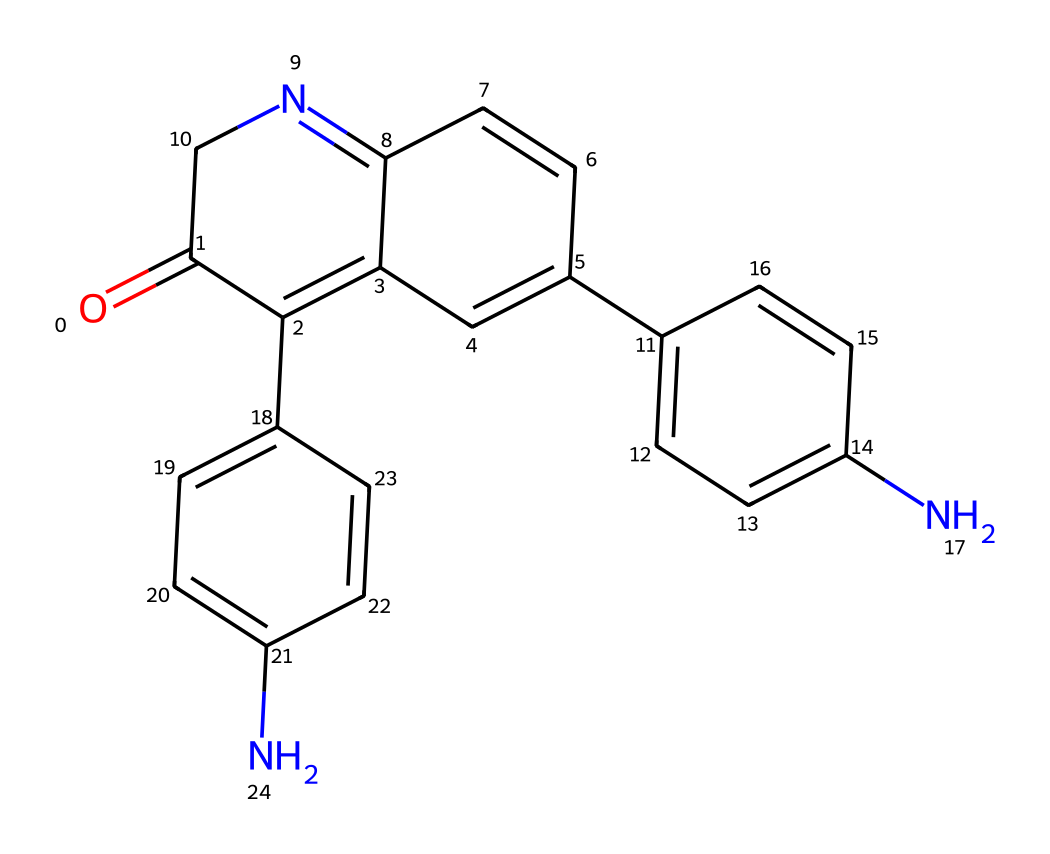What is the core structure of this indigo dye? The core structure of this indigo dye is based on a conjugated system with alternating double bonds, which is evident from the SMILES representation where multiple aromatic rings are present.
Answer: conjugated aromatic system How many nitrogen atoms are present in this compound? By analyzing the SMILES representation, we can identify the nitrogen atoms directly noted in the structure. There are three nitrogen atoms indicated in the representation.
Answer: three What type of chemical bonding is primarily responsible for the color of the indigo dye? The color of indigo dye arises from the delocalization of electrons across the pi bonds in the conjugated system, which is a result of resonance in the aromatic rings.
Answer: resonance How many rings are present in the structure? Observing the SMILES notation, we can find four distinct cyclic structures (rings) represented within the chemical composition.
Answer: four What are the functional groups present in this indigo dye? By examining the structure, we can identify key functional groups such as amines due to the presence of nitrogen atoms and carbonyl groups suggested by the "=" signs in the SMILES.
Answer: amines, carbonyls Is this compound a natural or synthetic dye? Indigo dye has a long history of being derived from natural sources (like the indigo plant) but can also be synthesized chemically, indicating its dual origin.
Answer: natural and synthetic 